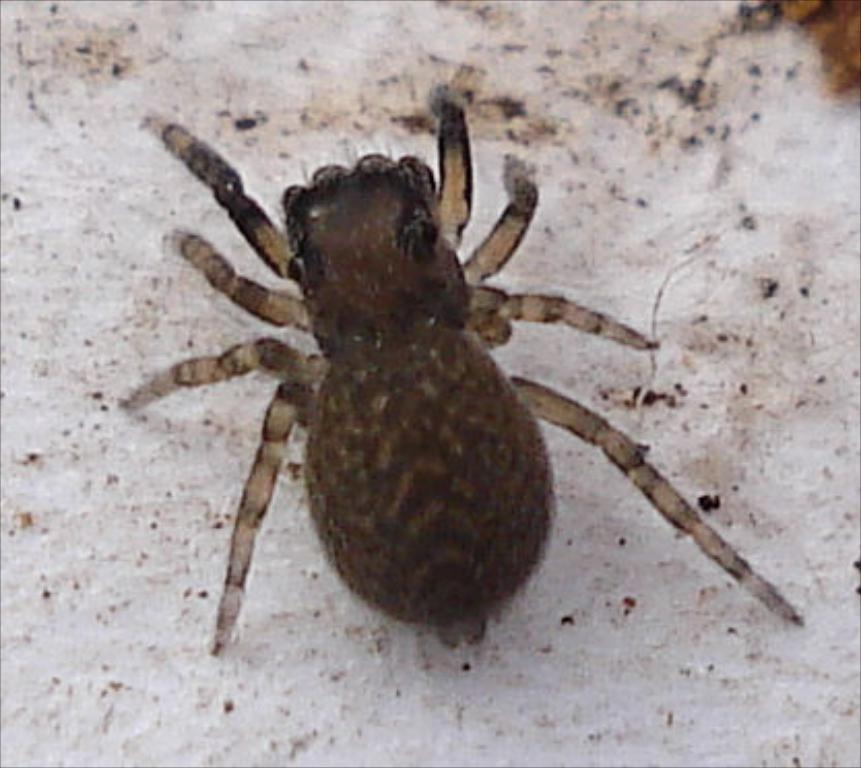What type of creature can be seen in the image? There is an insect in the image. Where is the insect located? The insect is on a surface. What type of nose can be seen in the image? There is no nose present in the image; it features an insect on a surface. What type of mine is visible in the image? There is no mine present in the image; it features an insect on a surface. 